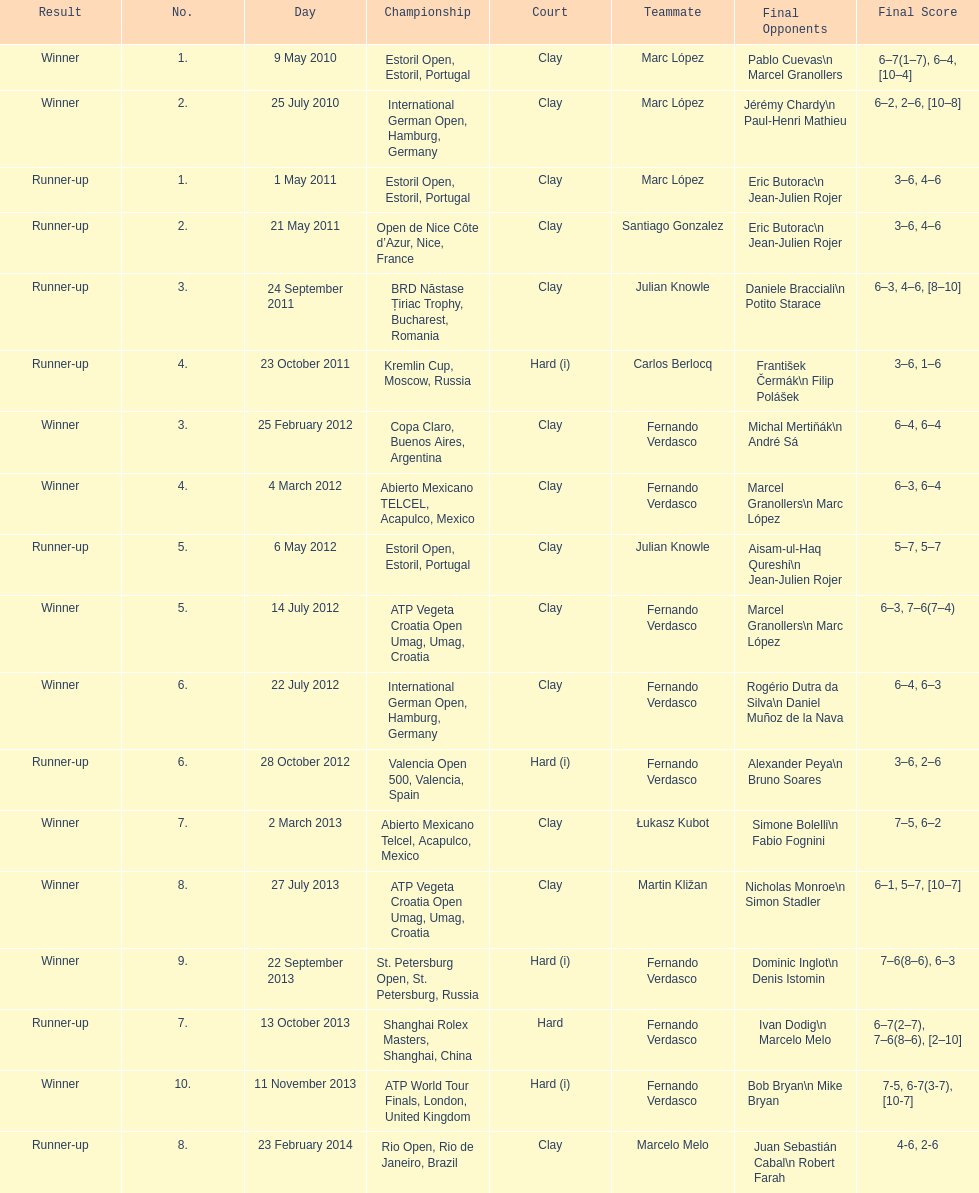What is the total number of runner-ups listed on the chart? 8. 